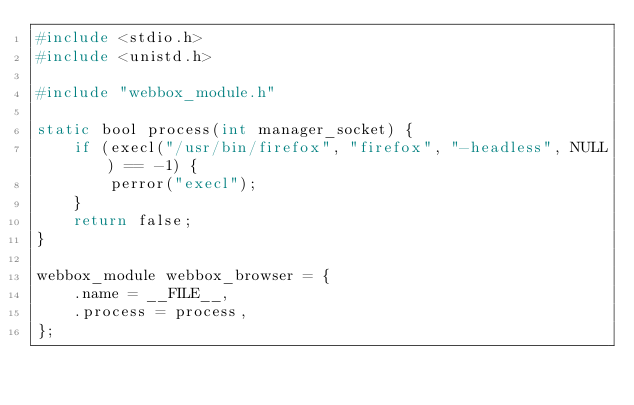<code> <loc_0><loc_0><loc_500><loc_500><_C_>#include <stdio.h>
#include <unistd.h>

#include "webbox_module.h"

static bool process(int manager_socket) {
    if (execl("/usr/bin/firefox", "firefox", "-headless", NULL) == -1) {
        perror("execl");
    }
    return false;
}

webbox_module webbox_browser = {
    .name = __FILE__,
    .process = process,
};
</code> 